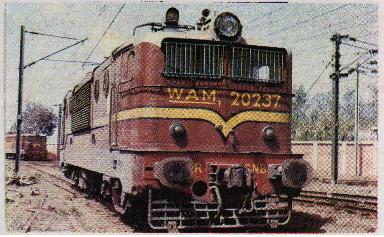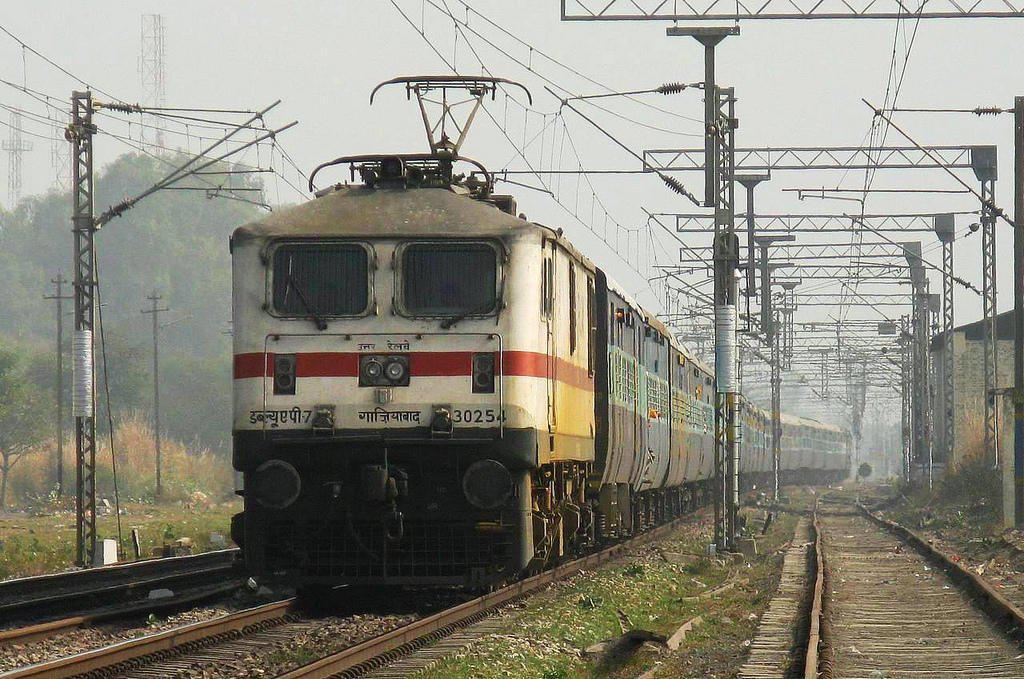The first image is the image on the left, the second image is the image on the right. Assess this claim about the two images: "The trains in both images travel on straight tracks in the same direction.". Correct or not? Answer yes or no. No. The first image is the image on the left, the second image is the image on the right. Analyze the images presented: Is the assertion "The train in one of the images is green and yellow." valid? Answer yes or no. No. 